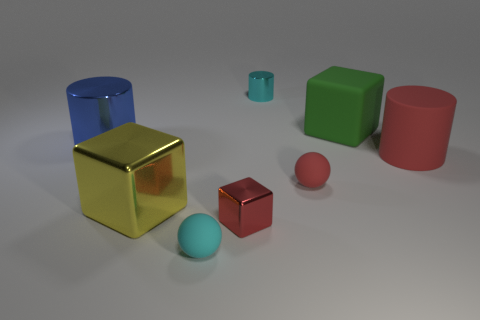Add 1 tiny red matte spheres. How many objects exist? 9 Subtract all cylinders. How many objects are left? 5 Add 5 large red matte things. How many large red matte things exist? 6 Subtract 1 red spheres. How many objects are left? 7 Subtract all cubes. Subtract all gray cylinders. How many objects are left? 5 Add 5 large shiny cylinders. How many large shiny cylinders are left? 6 